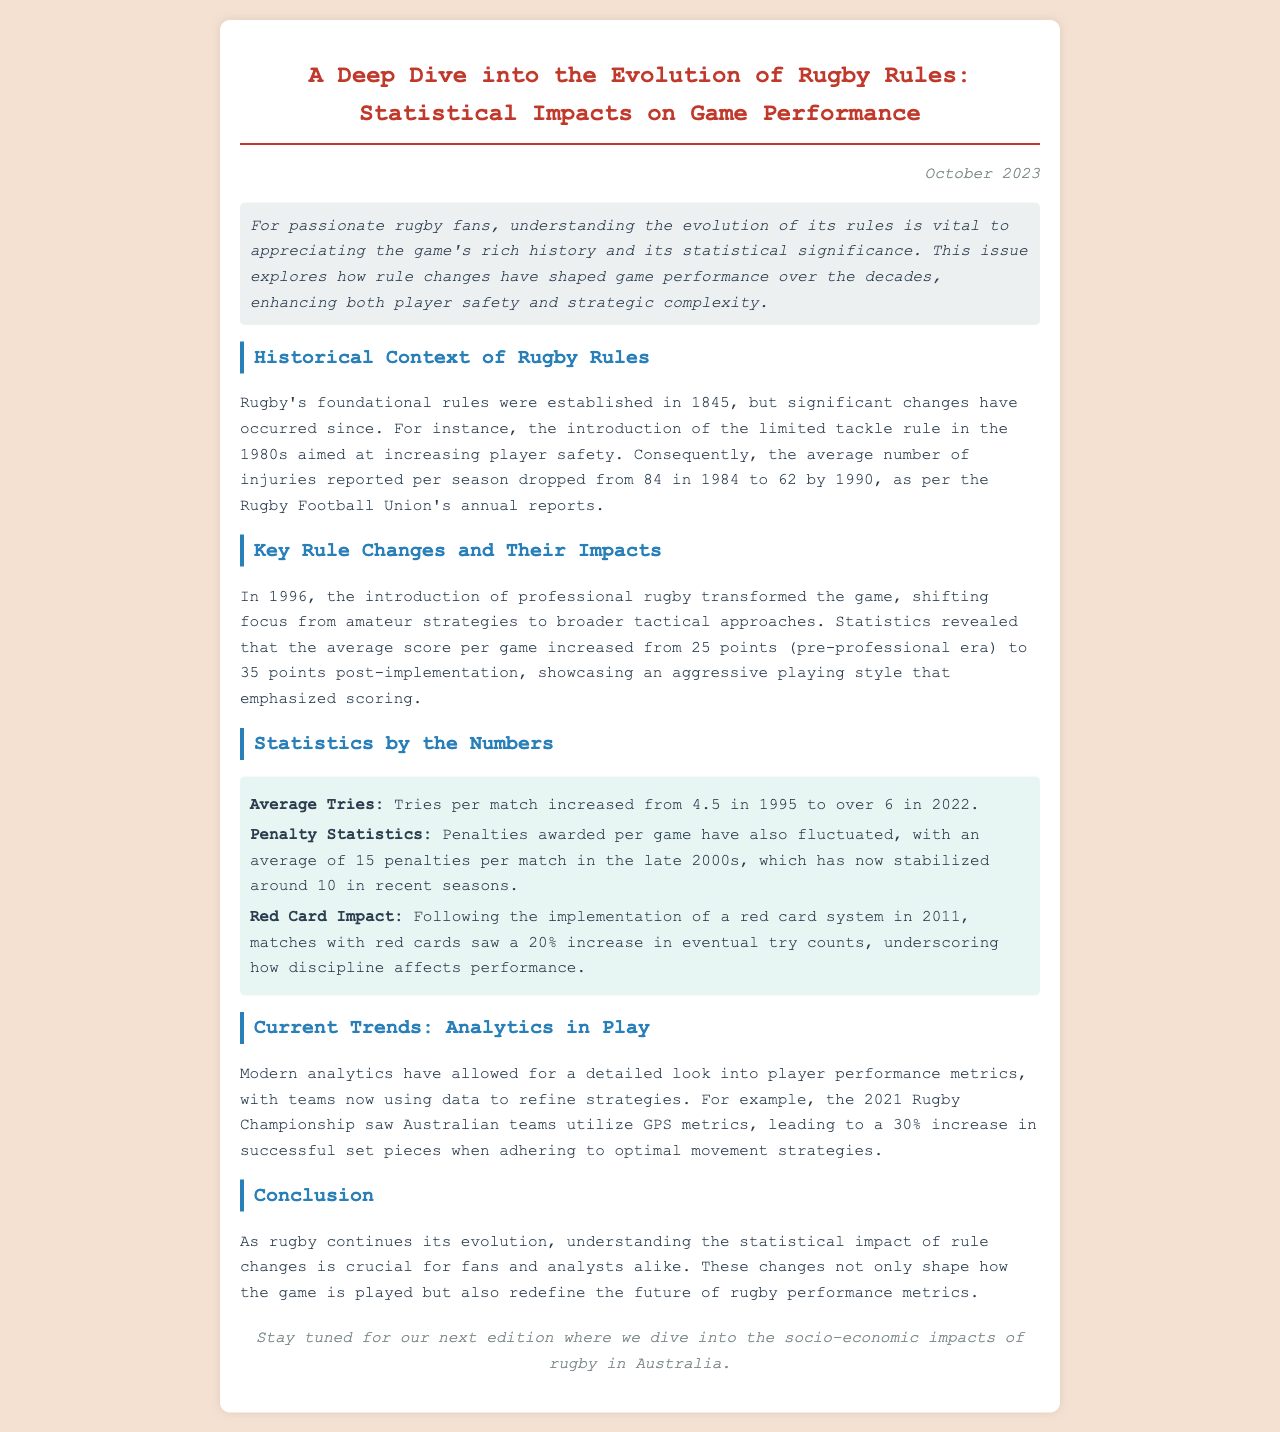What year were rugby's foundational rules established? The document states that rugby's foundational rules were established in 1845.
Answer: 1845 What was the average number of injuries reported per season in 1984? The average number of injuries reported per season in 1984 was 84.
Answer: 84 How many points did the average score per game increase to after the professional rugby era began? The average score per game increased from 25 points to 35 points post-implementation of professional rugby in 1996.
Answer: 35 points What was the average tries per match in 1995? The average tries per match in 1995 was 4.5.
Answer: 4.5 By what percentage did try counts increase in matches with red cards after 2011? Following the implementation of a red card system in 2011, matches with red cards saw a 20% increase in try counts.
Answer: 20% What significant percentage increase did Australian teams experience in successful set pieces in 2021? The document mentions a 30% increase in successful set pieces due to data refinement strategies.
Answer: 30% What is the title of the newsletter? The title of the newsletter is "A Deep Dive into the Evolution of Rugby Rules: Statistical Impacts on Game Performance."
Answer: A Deep Dive into the Evolution of Rugby Rules: Statistical Impacts on Game Performance What is the date of publication for this newsletter? The date of publication for the newsletter is October 2023.
Answer: October 2023 